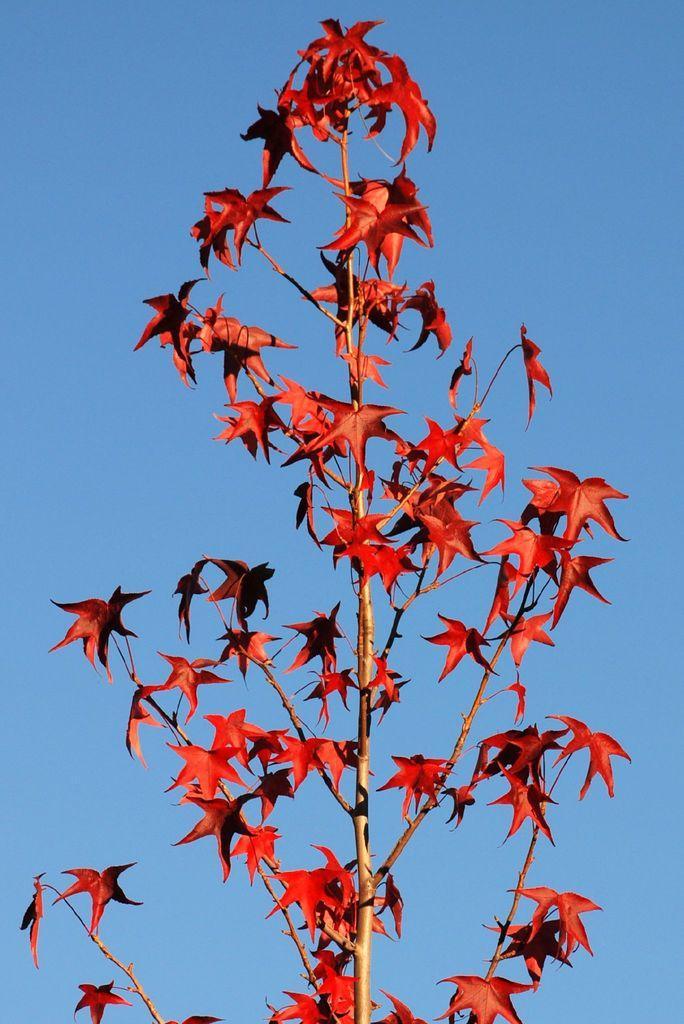How would you summarize this image in a sentence or two? In this image we can see a tree with leaves. 